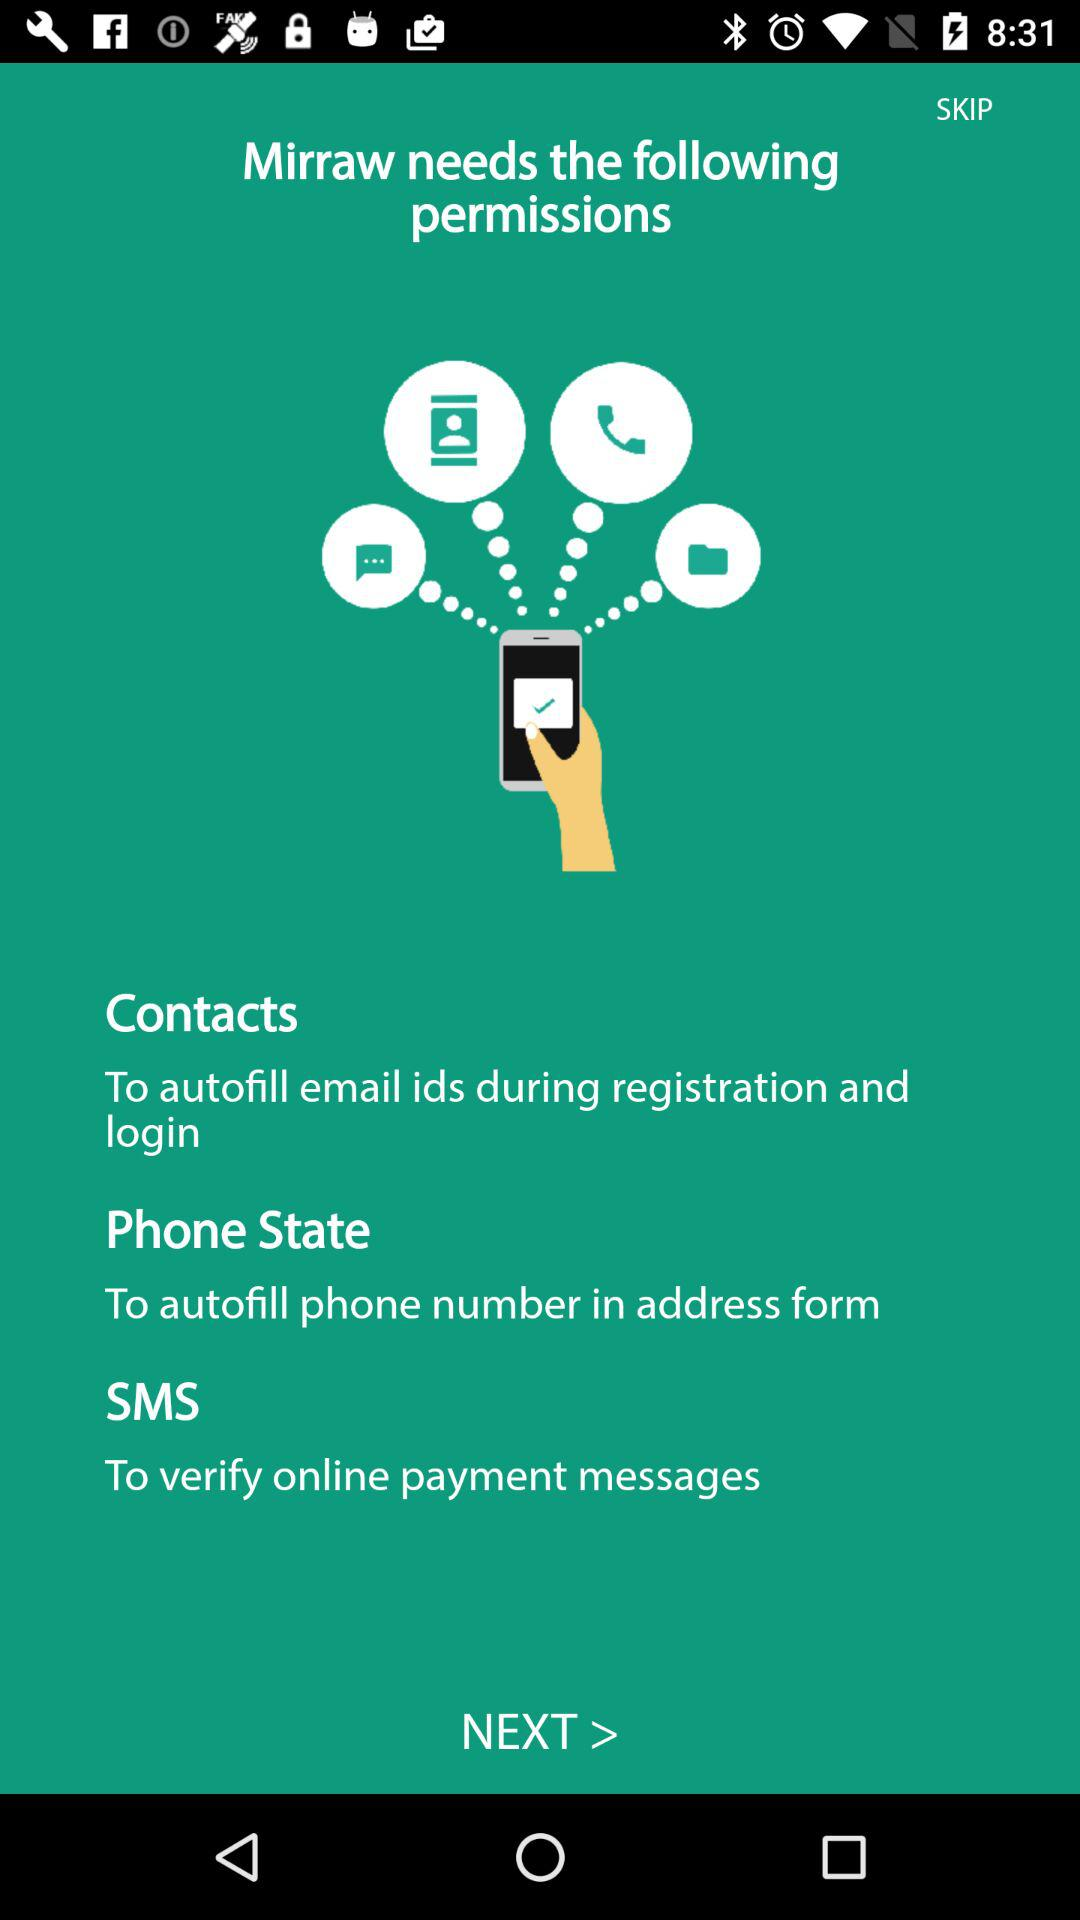How many permission items are there?
Answer the question using a single word or phrase. 3 